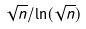<formula> <loc_0><loc_0><loc_500><loc_500>\sqrt { n } / \ln ( \sqrt { n } )</formula> 